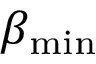Convert formula to latex. <formula><loc_0><loc_0><loc_500><loc_500>\beta _ { \min }</formula> 